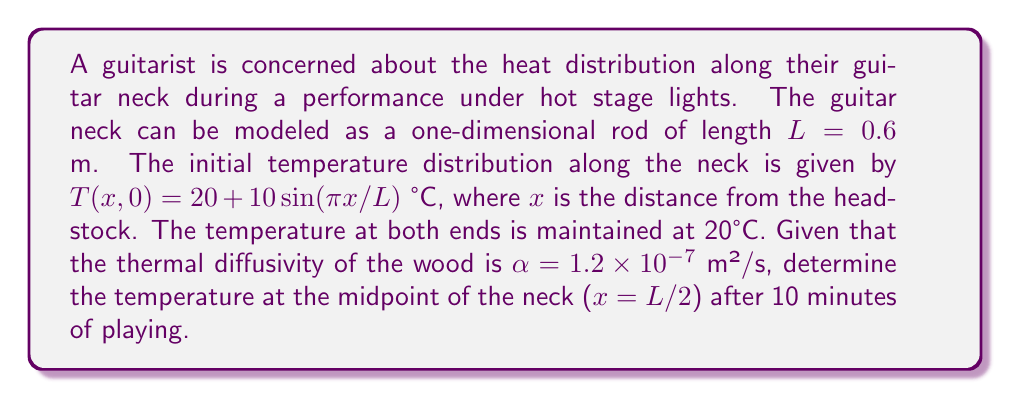Can you solve this math problem? To solve this problem, we'll use the heat equation and follow these steps:

1) The heat equation in one dimension is:

   $$\frac{\partial T}{\partial t} = \alpha \frac{\partial^2 T}{\partial x^2}$$

2) Given the boundary conditions (T = 20°C at x = 0 and x = L) and the initial condition, we can use the method of separation of variables. The solution will have the form:

   $$T(x,t) = 20 + \sum_{n=1}^{\infty} B_n \sin(\frac{n\pi x}{L}) e^{-\alpha(\frac{n\pi}{L})^2 t}$$

3) The initial condition matches the n = 1 term of this series, so we only need to consider this term:

   $$T(x,t) = 20 + 10 \sin(\frac{\pi x}{L}) e^{-\alpha(\frac{\pi}{L})^2 t}$$

4) We need to find T(L/2, 600), as 10 minutes = 600 seconds:

   $$T(L/2, 600) = 20 + 10 \sin(\frac{\pi (L/2)}{L}) e^{-\alpha(\frac{\pi}{L})^2 600}$$

5) Simplify $\sin(\frac{\pi (L/2)}{L}) = \sin(\frac{\pi}{2}) = 1$:

   $$T(L/2, 600) = 20 + 10 e^{-\alpha(\frac{\pi}{L})^2 600}$$

6) Substitute the values: $\alpha = 1.2 \times 10^{-7}$ m²/s, $L = 0.6$ m:

   $$T(L/2, 600) = 20 + 10 e^{-(1.2 \times 10^{-7})(\frac{\pi}{0.6})^2 600}$$

7) Calculate:

   $$T(L/2, 600) = 20 + 10 e^{-0.3944} \approx 26.74°C$$
Answer: 26.74°C 